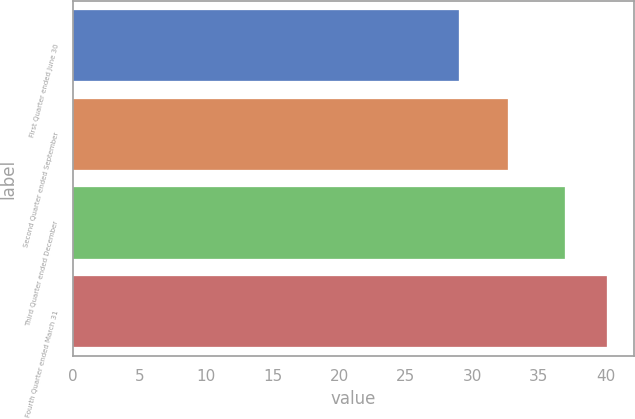Convert chart to OTSL. <chart><loc_0><loc_0><loc_500><loc_500><bar_chart><fcel>First Quarter ended June 30<fcel>Second Quarter ended September<fcel>Third Quarter ended December<fcel>Fourth Quarter ended March 31<nl><fcel>28.98<fcel>32.71<fcel>37<fcel>40.12<nl></chart> 